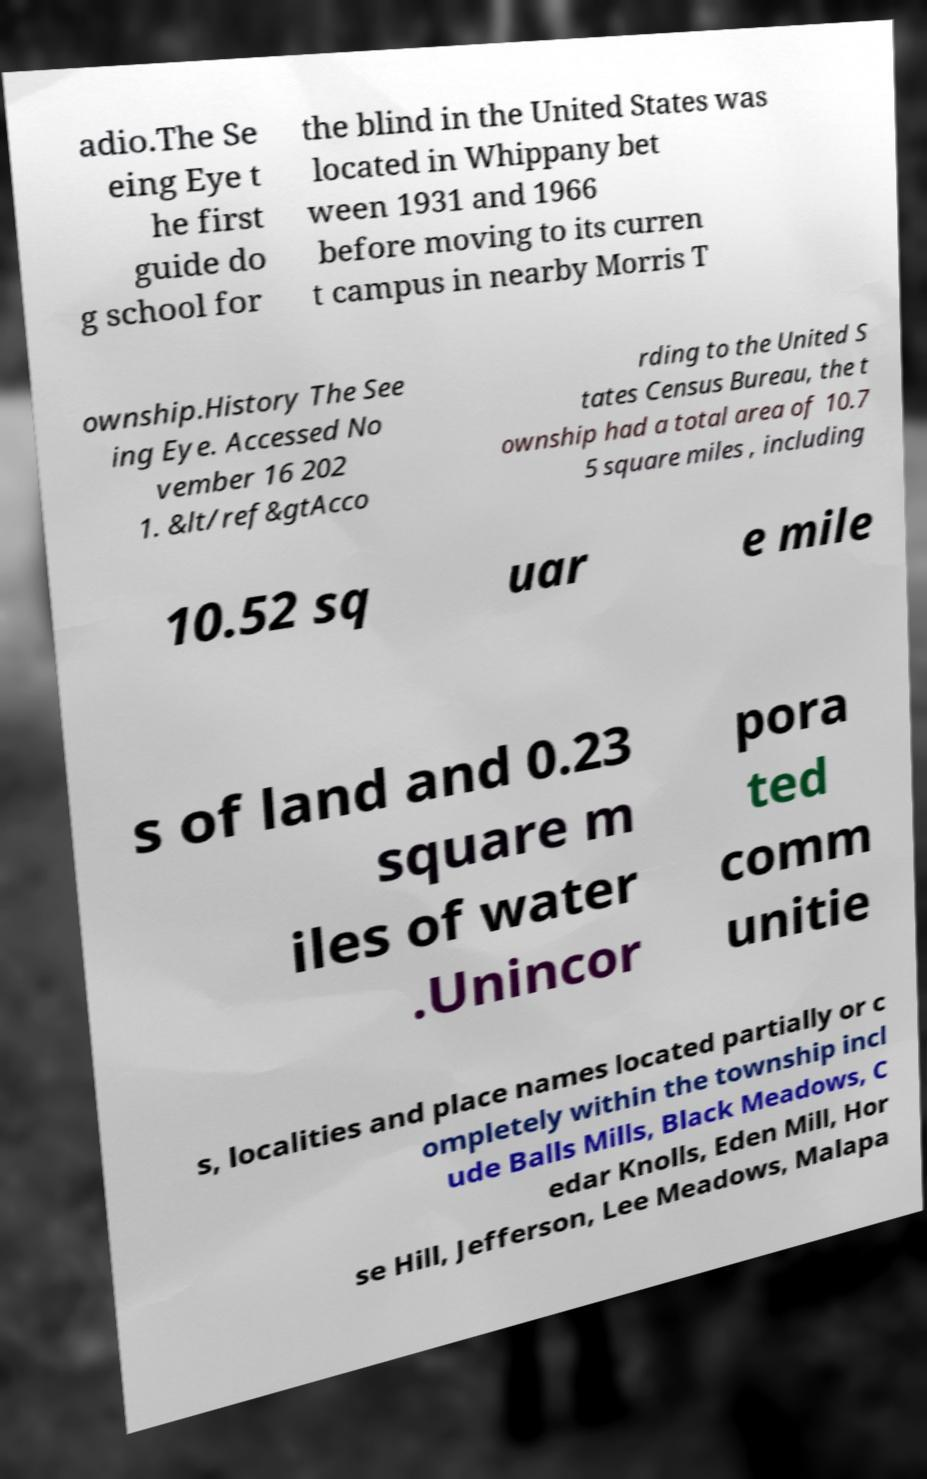Can you accurately transcribe the text from the provided image for me? adio.The Se eing Eye t he first guide do g school for the blind in the United States was located in Whippany bet ween 1931 and 1966 before moving to its curren t campus in nearby Morris T ownship.History The See ing Eye. Accessed No vember 16 202 1. &lt/ref&gtAcco rding to the United S tates Census Bureau, the t ownship had a total area of 10.7 5 square miles , including 10.52 sq uar e mile s of land and 0.23 square m iles of water .Unincor pora ted comm unitie s, localities and place names located partially or c ompletely within the township incl ude Balls Mills, Black Meadows, C edar Knolls, Eden Mill, Hor se Hill, Jefferson, Lee Meadows, Malapa 